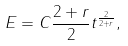<formula> <loc_0><loc_0><loc_500><loc_500>E = C \frac { 2 + r } { 2 } t ^ { \frac { 2 } { 2 + r } } ,</formula> 